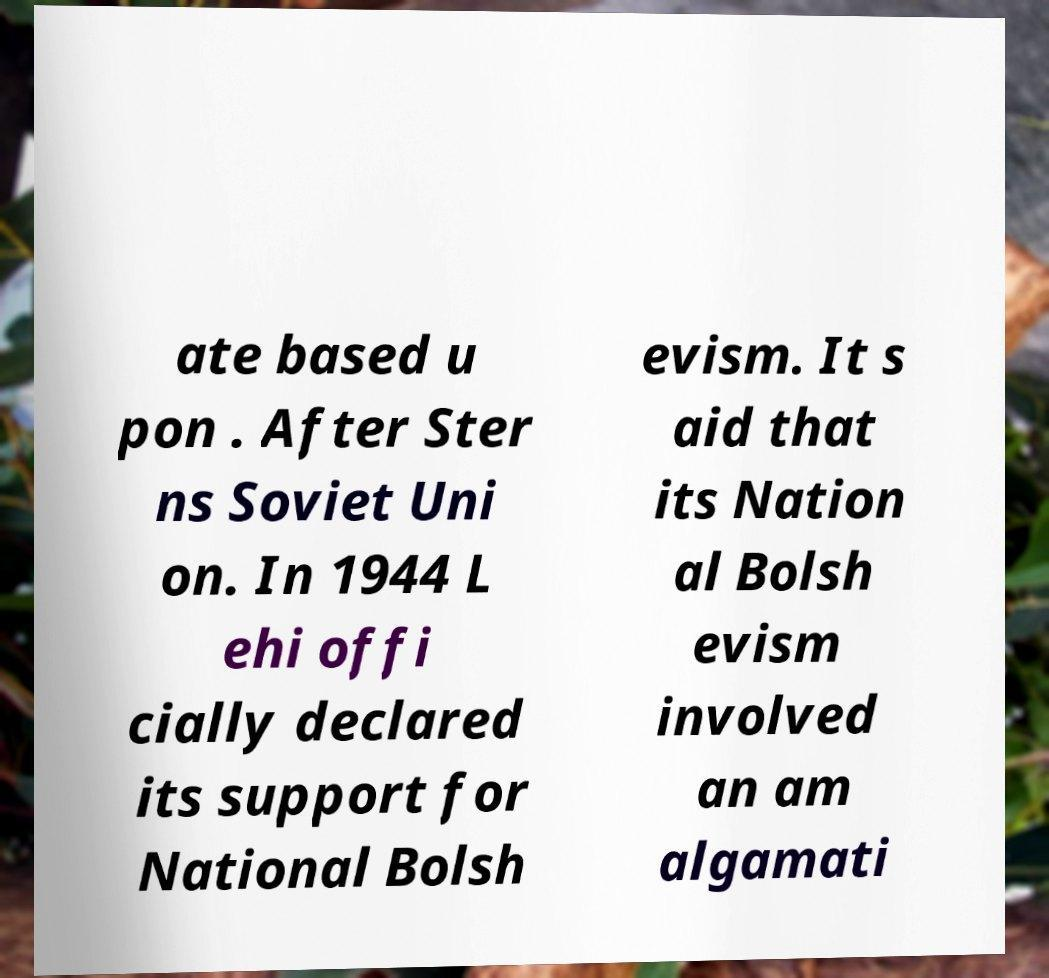I need the written content from this picture converted into text. Can you do that? ate based u pon . After Ster ns Soviet Uni on. In 1944 L ehi offi cially declared its support for National Bolsh evism. It s aid that its Nation al Bolsh evism involved an am algamati 